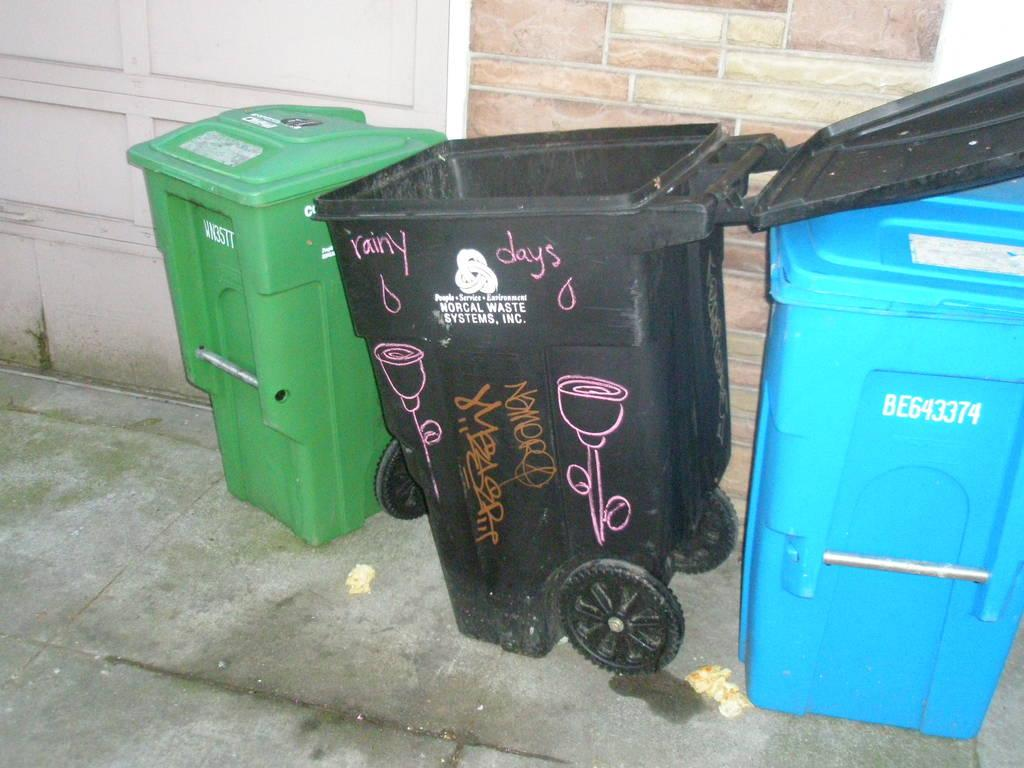<image>
Create a compact narrative representing the image presented. Blue garbage can with the numbers BE643374 next to a black garbage can. 